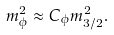Convert formula to latex. <formula><loc_0><loc_0><loc_500><loc_500>m _ { \phi } ^ { 2 } \approx C _ { \phi } m _ { 3 / 2 } ^ { 2 } .</formula> 